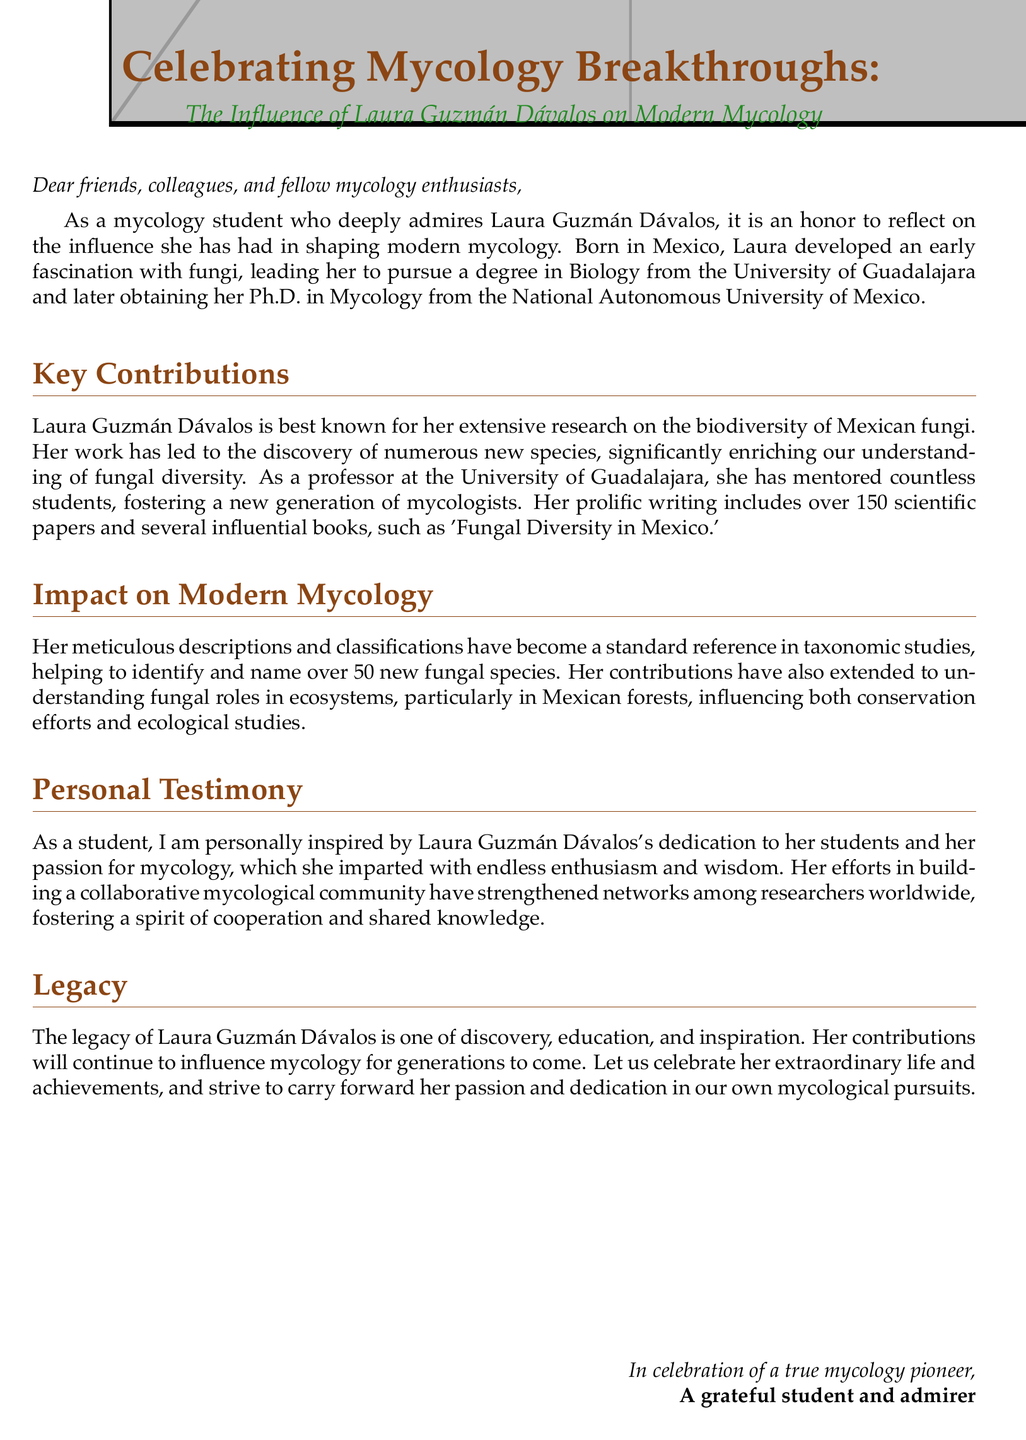What university did Laura Guzmán Dávalos attend for her Ph.D.? The document states that she obtained her Ph.D. in Mycology from the National Autonomous University of Mexico.
Answer: National Autonomous University of Mexico How many scientific papers has Laura Guzmán Dávalos written? The document mentions that her prolific writing includes over 150 scientific papers.
Answer: Over 150 What significant contribution did Laura make in taxonomic studies? It is stated that Laura helped to identify and name over 50 new fungal species.
Answer: Over 50 new fungal species What is one of the influential books authored by Laura? The document lists 'Fungal Diversity in Mexico' as one of her influential books.
Answer: Fungal Diversity in Mexico What is Laura's birthplace? The document notes that Laura was born in Mexico.
Answer: Mexico How has Laura influenced conservation efforts? Laura's research has influenced conservation efforts by improving understanding of fungal roles in ecosystems.
Answer: Understanding of fungal roles in ecosystems What is a key theme in Laura's legacy? The document mentions discovery, education, and inspiration as key themes in Laura's legacy.
Answer: Discovery, education, and inspiration What type of community has Laura built among researchers? The document states that she has built a collaborative mycological community.
Answer: Collaborative mycological community 